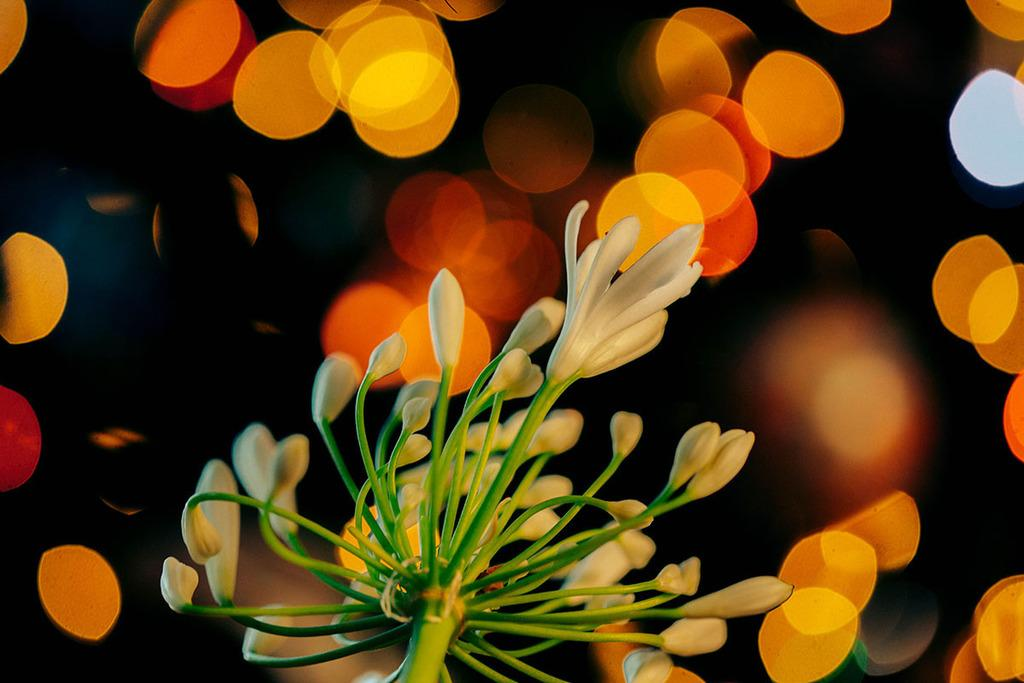What type of plant is in the image? There is a flowering plant in the image. What else can be seen in the image besides the plant? Lights are visible in the image. Can you describe the lighting conditions in the image? The image appears to be taken during the night, as indicated by the mention of a "dark color." What type of ornament is hanging from the jeans in the image? There is no mention of jeans or an ornament in the image; it features a flowering plant and lights. 